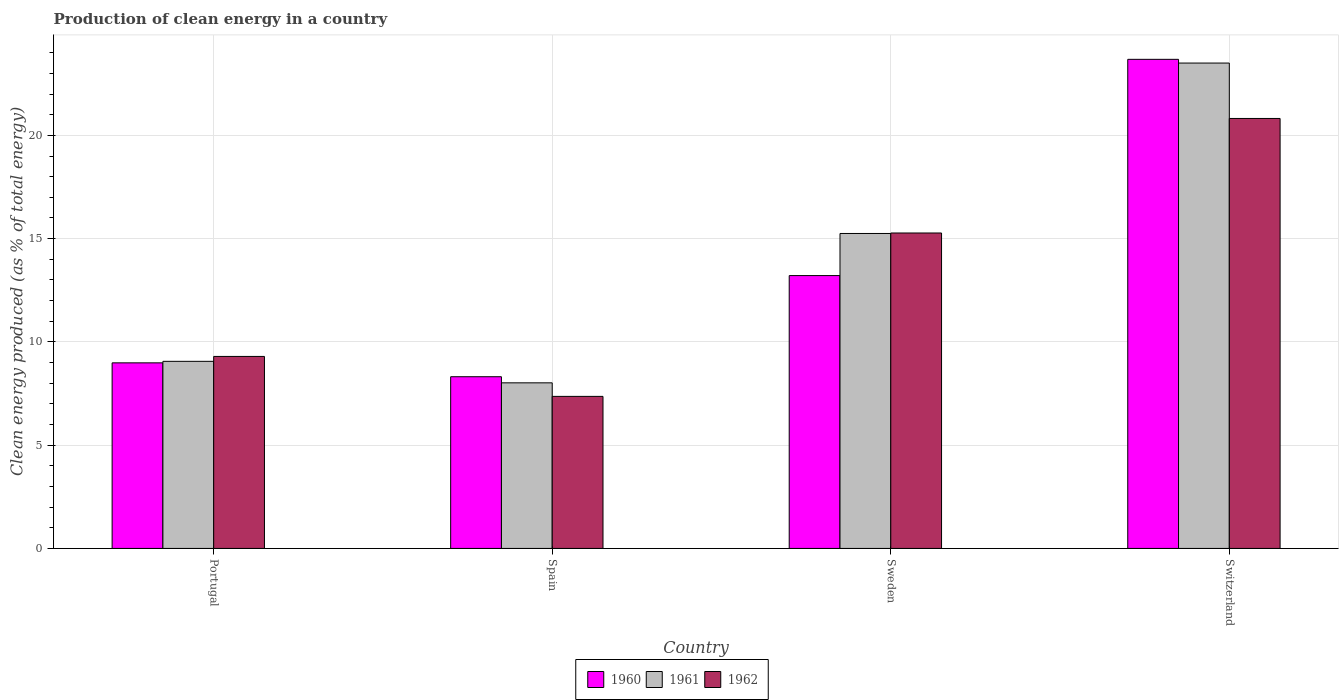How many groups of bars are there?
Give a very brief answer. 4. Are the number of bars on each tick of the X-axis equal?
Make the answer very short. Yes. How many bars are there on the 3rd tick from the left?
Your answer should be very brief. 3. What is the label of the 1st group of bars from the left?
Make the answer very short. Portugal. In how many cases, is the number of bars for a given country not equal to the number of legend labels?
Offer a terse response. 0. What is the percentage of clean energy produced in 1960 in Spain?
Offer a very short reply. 8.31. Across all countries, what is the maximum percentage of clean energy produced in 1962?
Offer a very short reply. 20.82. Across all countries, what is the minimum percentage of clean energy produced in 1960?
Offer a terse response. 8.31. In which country was the percentage of clean energy produced in 1961 maximum?
Offer a terse response. Switzerland. In which country was the percentage of clean energy produced in 1961 minimum?
Ensure brevity in your answer.  Spain. What is the total percentage of clean energy produced in 1960 in the graph?
Your answer should be compact. 54.19. What is the difference between the percentage of clean energy produced in 1962 in Portugal and that in Spain?
Provide a succinct answer. 1.94. What is the difference between the percentage of clean energy produced in 1960 in Switzerland and the percentage of clean energy produced in 1961 in Portugal?
Keep it short and to the point. 14.62. What is the average percentage of clean energy produced in 1960 per country?
Ensure brevity in your answer.  13.55. What is the difference between the percentage of clean energy produced of/in 1961 and percentage of clean energy produced of/in 1960 in Portugal?
Offer a terse response. 0.07. What is the ratio of the percentage of clean energy produced in 1962 in Portugal to that in Sweden?
Your answer should be compact. 0.61. Is the percentage of clean energy produced in 1962 in Spain less than that in Sweden?
Make the answer very short. Yes. What is the difference between the highest and the second highest percentage of clean energy produced in 1962?
Offer a terse response. -11.52. What is the difference between the highest and the lowest percentage of clean energy produced in 1960?
Your answer should be very brief. 15.37. In how many countries, is the percentage of clean energy produced in 1962 greater than the average percentage of clean energy produced in 1962 taken over all countries?
Provide a succinct answer. 2. What does the 3rd bar from the right in Sweden represents?
Offer a very short reply. 1960. Are all the bars in the graph horizontal?
Your response must be concise. No. Are the values on the major ticks of Y-axis written in scientific E-notation?
Offer a very short reply. No. Does the graph contain grids?
Offer a very short reply. Yes. Where does the legend appear in the graph?
Keep it short and to the point. Bottom center. What is the title of the graph?
Offer a terse response. Production of clean energy in a country. Does "1989" appear as one of the legend labels in the graph?
Keep it short and to the point. No. What is the label or title of the Y-axis?
Make the answer very short. Clean energy produced (as % of total energy). What is the Clean energy produced (as % of total energy) in 1960 in Portugal?
Your answer should be compact. 8.99. What is the Clean energy produced (as % of total energy) in 1961 in Portugal?
Offer a very short reply. 9.06. What is the Clean energy produced (as % of total energy) in 1962 in Portugal?
Offer a very short reply. 9.3. What is the Clean energy produced (as % of total energy) of 1960 in Spain?
Your answer should be very brief. 8.31. What is the Clean energy produced (as % of total energy) of 1961 in Spain?
Provide a succinct answer. 8.02. What is the Clean energy produced (as % of total energy) in 1962 in Spain?
Offer a very short reply. 7.36. What is the Clean energy produced (as % of total energy) of 1960 in Sweden?
Your answer should be very brief. 13.21. What is the Clean energy produced (as % of total energy) in 1961 in Sweden?
Keep it short and to the point. 15.25. What is the Clean energy produced (as % of total energy) of 1962 in Sweden?
Offer a very short reply. 15.27. What is the Clean energy produced (as % of total energy) of 1960 in Switzerland?
Your answer should be compact. 23.68. What is the Clean energy produced (as % of total energy) of 1961 in Switzerland?
Ensure brevity in your answer.  23.5. What is the Clean energy produced (as % of total energy) of 1962 in Switzerland?
Give a very brief answer. 20.82. Across all countries, what is the maximum Clean energy produced (as % of total energy) in 1960?
Offer a very short reply. 23.68. Across all countries, what is the maximum Clean energy produced (as % of total energy) of 1961?
Ensure brevity in your answer.  23.5. Across all countries, what is the maximum Clean energy produced (as % of total energy) in 1962?
Keep it short and to the point. 20.82. Across all countries, what is the minimum Clean energy produced (as % of total energy) in 1960?
Make the answer very short. 8.31. Across all countries, what is the minimum Clean energy produced (as % of total energy) of 1961?
Provide a short and direct response. 8.02. Across all countries, what is the minimum Clean energy produced (as % of total energy) in 1962?
Make the answer very short. 7.36. What is the total Clean energy produced (as % of total energy) of 1960 in the graph?
Your answer should be very brief. 54.19. What is the total Clean energy produced (as % of total energy) of 1961 in the graph?
Make the answer very short. 55.83. What is the total Clean energy produced (as % of total energy) in 1962 in the graph?
Give a very brief answer. 52.75. What is the difference between the Clean energy produced (as % of total energy) of 1960 in Portugal and that in Spain?
Keep it short and to the point. 0.67. What is the difference between the Clean energy produced (as % of total energy) in 1961 in Portugal and that in Spain?
Give a very brief answer. 1.04. What is the difference between the Clean energy produced (as % of total energy) in 1962 in Portugal and that in Spain?
Your answer should be compact. 1.94. What is the difference between the Clean energy produced (as % of total energy) of 1960 in Portugal and that in Sweden?
Provide a short and direct response. -4.23. What is the difference between the Clean energy produced (as % of total energy) of 1961 in Portugal and that in Sweden?
Your answer should be compact. -6.19. What is the difference between the Clean energy produced (as % of total energy) in 1962 in Portugal and that in Sweden?
Ensure brevity in your answer.  -5.98. What is the difference between the Clean energy produced (as % of total energy) in 1960 in Portugal and that in Switzerland?
Give a very brief answer. -14.7. What is the difference between the Clean energy produced (as % of total energy) of 1961 in Portugal and that in Switzerland?
Your answer should be very brief. -14.44. What is the difference between the Clean energy produced (as % of total energy) of 1962 in Portugal and that in Switzerland?
Keep it short and to the point. -11.52. What is the difference between the Clean energy produced (as % of total energy) of 1960 in Spain and that in Sweden?
Provide a short and direct response. -4.9. What is the difference between the Clean energy produced (as % of total energy) of 1961 in Spain and that in Sweden?
Make the answer very short. -7.23. What is the difference between the Clean energy produced (as % of total energy) of 1962 in Spain and that in Sweden?
Offer a very short reply. -7.91. What is the difference between the Clean energy produced (as % of total energy) in 1960 in Spain and that in Switzerland?
Your answer should be very brief. -15.37. What is the difference between the Clean energy produced (as % of total energy) of 1961 in Spain and that in Switzerland?
Give a very brief answer. -15.48. What is the difference between the Clean energy produced (as % of total energy) in 1962 in Spain and that in Switzerland?
Make the answer very short. -13.46. What is the difference between the Clean energy produced (as % of total energy) of 1960 in Sweden and that in Switzerland?
Give a very brief answer. -10.47. What is the difference between the Clean energy produced (as % of total energy) of 1961 in Sweden and that in Switzerland?
Offer a terse response. -8.25. What is the difference between the Clean energy produced (as % of total energy) in 1962 in Sweden and that in Switzerland?
Make the answer very short. -5.55. What is the difference between the Clean energy produced (as % of total energy) of 1960 in Portugal and the Clean energy produced (as % of total energy) of 1961 in Spain?
Your answer should be compact. 0.97. What is the difference between the Clean energy produced (as % of total energy) of 1960 in Portugal and the Clean energy produced (as % of total energy) of 1962 in Spain?
Make the answer very short. 1.62. What is the difference between the Clean energy produced (as % of total energy) of 1961 in Portugal and the Clean energy produced (as % of total energy) of 1962 in Spain?
Offer a very short reply. 1.7. What is the difference between the Clean energy produced (as % of total energy) in 1960 in Portugal and the Clean energy produced (as % of total energy) in 1961 in Sweden?
Provide a short and direct response. -6.26. What is the difference between the Clean energy produced (as % of total energy) of 1960 in Portugal and the Clean energy produced (as % of total energy) of 1962 in Sweden?
Your response must be concise. -6.29. What is the difference between the Clean energy produced (as % of total energy) in 1961 in Portugal and the Clean energy produced (as % of total energy) in 1962 in Sweden?
Your response must be concise. -6.21. What is the difference between the Clean energy produced (as % of total energy) in 1960 in Portugal and the Clean energy produced (as % of total energy) in 1961 in Switzerland?
Ensure brevity in your answer.  -14.52. What is the difference between the Clean energy produced (as % of total energy) of 1960 in Portugal and the Clean energy produced (as % of total energy) of 1962 in Switzerland?
Offer a very short reply. -11.83. What is the difference between the Clean energy produced (as % of total energy) in 1961 in Portugal and the Clean energy produced (as % of total energy) in 1962 in Switzerland?
Provide a succinct answer. -11.76. What is the difference between the Clean energy produced (as % of total energy) in 1960 in Spain and the Clean energy produced (as % of total energy) in 1961 in Sweden?
Provide a short and direct response. -6.94. What is the difference between the Clean energy produced (as % of total energy) of 1960 in Spain and the Clean energy produced (as % of total energy) of 1962 in Sweden?
Ensure brevity in your answer.  -6.96. What is the difference between the Clean energy produced (as % of total energy) of 1961 in Spain and the Clean energy produced (as % of total energy) of 1962 in Sweden?
Provide a short and direct response. -7.26. What is the difference between the Clean energy produced (as % of total energy) in 1960 in Spain and the Clean energy produced (as % of total energy) in 1961 in Switzerland?
Your response must be concise. -15.19. What is the difference between the Clean energy produced (as % of total energy) in 1960 in Spain and the Clean energy produced (as % of total energy) in 1962 in Switzerland?
Provide a succinct answer. -12.5. What is the difference between the Clean energy produced (as % of total energy) in 1961 in Spain and the Clean energy produced (as % of total energy) in 1962 in Switzerland?
Make the answer very short. -12.8. What is the difference between the Clean energy produced (as % of total energy) of 1960 in Sweden and the Clean energy produced (as % of total energy) of 1961 in Switzerland?
Provide a succinct answer. -10.29. What is the difference between the Clean energy produced (as % of total energy) of 1960 in Sweden and the Clean energy produced (as % of total energy) of 1962 in Switzerland?
Give a very brief answer. -7.61. What is the difference between the Clean energy produced (as % of total energy) of 1961 in Sweden and the Clean energy produced (as % of total energy) of 1962 in Switzerland?
Ensure brevity in your answer.  -5.57. What is the average Clean energy produced (as % of total energy) in 1960 per country?
Provide a succinct answer. 13.55. What is the average Clean energy produced (as % of total energy) in 1961 per country?
Your response must be concise. 13.96. What is the average Clean energy produced (as % of total energy) of 1962 per country?
Ensure brevity in your answer.  13.19. What is the difference between the Clean energy produced (as % of total energy) in 1960 and Clean energy produced (as % of total energy) in 1961 in Portugal?
Give a very brief answer. -0.07. What is the difference between the Clean energy produced (as % of total energy) of 1960 and Clean energy produced (as % of total energy) of 1962 in Portugal?
Ensure brevity in your answer.  -0.31. What is the difference between the Clean energy produced (as % of total energy) in 1961 and Clean energy produced (as % of total energy) in 1962 in Portugal?
Keep it short and to the point. -0.24. What is the difference between the Clean energy produced (as % of total energy) of 1960 and Clean energy produced (as % of total energy) of 1961 in Spain?
Offer a terse response. 0.3. What is the difference between the Clean energy produced (as % of total energy) of 1960 and Clean energy produced (as % of total energy) of 1962 in Spain?
Provide a short and direct response. 0.95. What is the difference between the Clean energy produced (as % of total energy) in 1961 and Clean energy produced (as % of total energy) in 1962 in Spain?
Offer a very short reply. 0.66. What is the difference between the Clean energy produced (as % of total energy) in 1960 and Clean energy produced (as % of total energy) in 1961 in Sweden?
Offer a very short reply. -2.04. What is the difference between the Clean energy produced (as % of total energy) of 1960 and Clean energy produced (as % of total energy) of 1962 in Sweden?
Make the answer very short. -2.06. What is the difference between the Clean energy produced (as % of total energy) of 1961 and Clean energy produced (as % of total energy) of 1962 in Sweden?
Give a very brief answer. -0.02. What is the difference between the Clean energy produced (as % of total energy) of 1960 and Clean energy produced (as % of total energy) of 1961 in Switzerland?
Keep it short and to the point. 0.18. What is the difference between the Clean energy produced (as % of total energy) of 1960 and Clean energy produced (as % of total energy) of 1962 in Switzerland?
Offer a terse response. 2.86. What is the difference between the Clean energy produced (as % of total energy) in 1961 and Clean energy produced (as % of total energy) in 1962 in Switzerland?
Your answer should be very brief. 2.68. What is the ratio of the Clean energy produced (as % of total energy) of 1960 in Portugal to that in Spain?
Ensure brevity in your answer.  1.08. What is the ratio of the Clean energy produced (as % of total energy) in 1961 in Portugal to that in Spain?
Your response must be concise. 1.13. What is the ratio of the Clean energy produced (as % of total energy) of 1962 in Portugal to that in Spain?
Offer a terse response. 1.26. What is the ratio of the Clean energy produced (as % of total energy) in 1960 in Portugal to that in Sweden?
Provide a succinct answer. 0.68. What is the ratio of the Clean energy produced (as % of total energy) in 1961 in Portugal to that in Sweden?
Provide a succinct answer. 0.59. What is the ratio of the Clean energy produced (as % of total energy) in 1962 in Portugal to that in Sweden?
Offer a very short reply. 0.61. What is the ratio of the Clean energy produced (as % of total energy) in 1960 in Portugal to that in Switzerland?
Give a very brief answer. 0.38. What is the ratio of the Clean energy produced (as % of total energy) in 1961 in Portugal to that in Switzerland?
Your response must be concise. 0.39. What is the ratio of the Clean energy produced (as % of total energy) in 1962 in Portugal to that in Switzerland?
Your answer should be compact. 0.45. What is the ratio of the Clean energy produced (as % of total energy) in 1960 in Spain to that in Sweden?
Keep it short and to the point. 0.63. What is the ratio of the Clean energy produced (as % of total energy) in 1961 in Spain to that in Sweden?
Offer a very short reply. 0.53. What is the ratio of the Clean energy produced (as % of total energy) of 1962 in Spain to that in Sweden?
Ensure brevity in your answer.  0.48. What is the ratio of the Clean energy produced (as % of total energy) in 1960 in Spain to that in Switzerland?
Your answer should be very brief. 0.35. What is the ratio of the Clean energy produced (as % of total energy) of 1961 in Spain to that in Switzerland?
Offer a terse response. 0.34. What is the ratio of the Clean energy produced (as % of total energy) in 1962 in Spain to that in Switzerland?
Provide a short and direct response. 0.35. What is the ratio of the Clean energy produced (as % of total energy) of 1960 in Sweden to that in Switzerland?
Ensure brevity in your answer.  0.56. What is the ratio of the Clean energy produced (as % of total energy) of 1961 in Sweden to that in Switzerland?
Give a very brief answer. 0.65. What is the ratio of the Clean energy produced (as % of total energy) of 1962 in Sweden to that in Switzerland?
Your answer should be compact. 0.73. What is the difference between the highest and the second highest Clean energy produced (as % of total energy) in 1960?
Your response must be concise. 10.47. What is the difference between the highest and the second highest Clean energy produced (as % of total energy) of 1961?
Offer a very short reply. 8.25. What is the difference between the highest and the second highest Clean energy produced (as % of total energy) in 1962?
Your answer should be compact. 5.55. What is the difference between the highest and the lowest Clean energy produced (as % of total energy) of 1960?
Give a very brief answer. 15.37. What is the difference between the highest and the lowest Clean energy produced (as % of total energy) of 1961?
Your response must be concise. 15.48. What is the difference between the highest and the lowest Clean energy produced (as % of total energy) of 1962?
Ensure brevity in your answer.  13.46. 